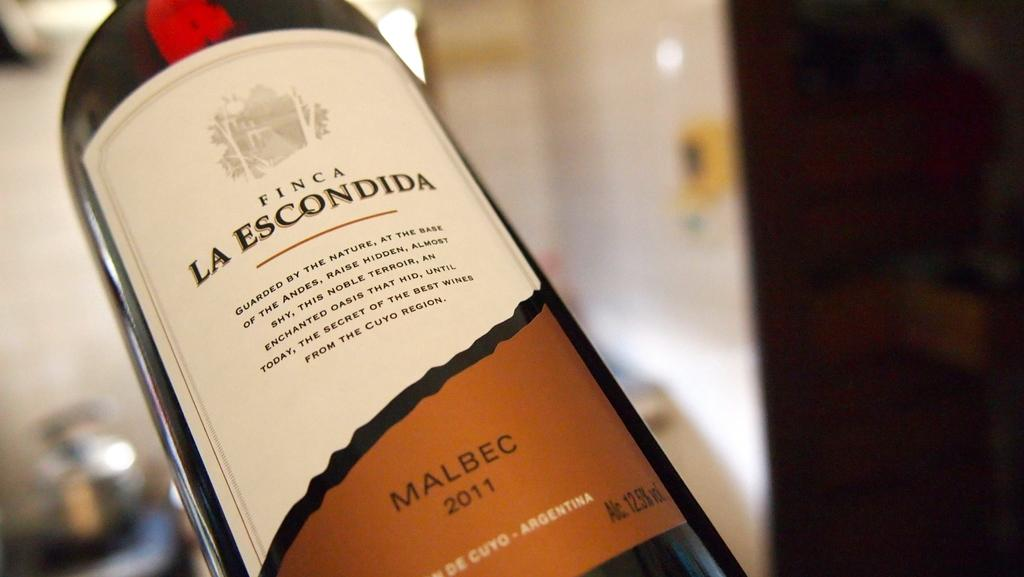Provide a one-sentence caption for the provided image. Bottle of Finca La escondida wine that is up close in picture. 